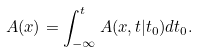Convert formula to latex. <formula><loc_0><loc_0><loc_500><loc_500>A ( x ) = \int _ { - \infty } ^ { t } A ( x , t | t _ { 0 } ) d t _ { 0 } .</formula> 